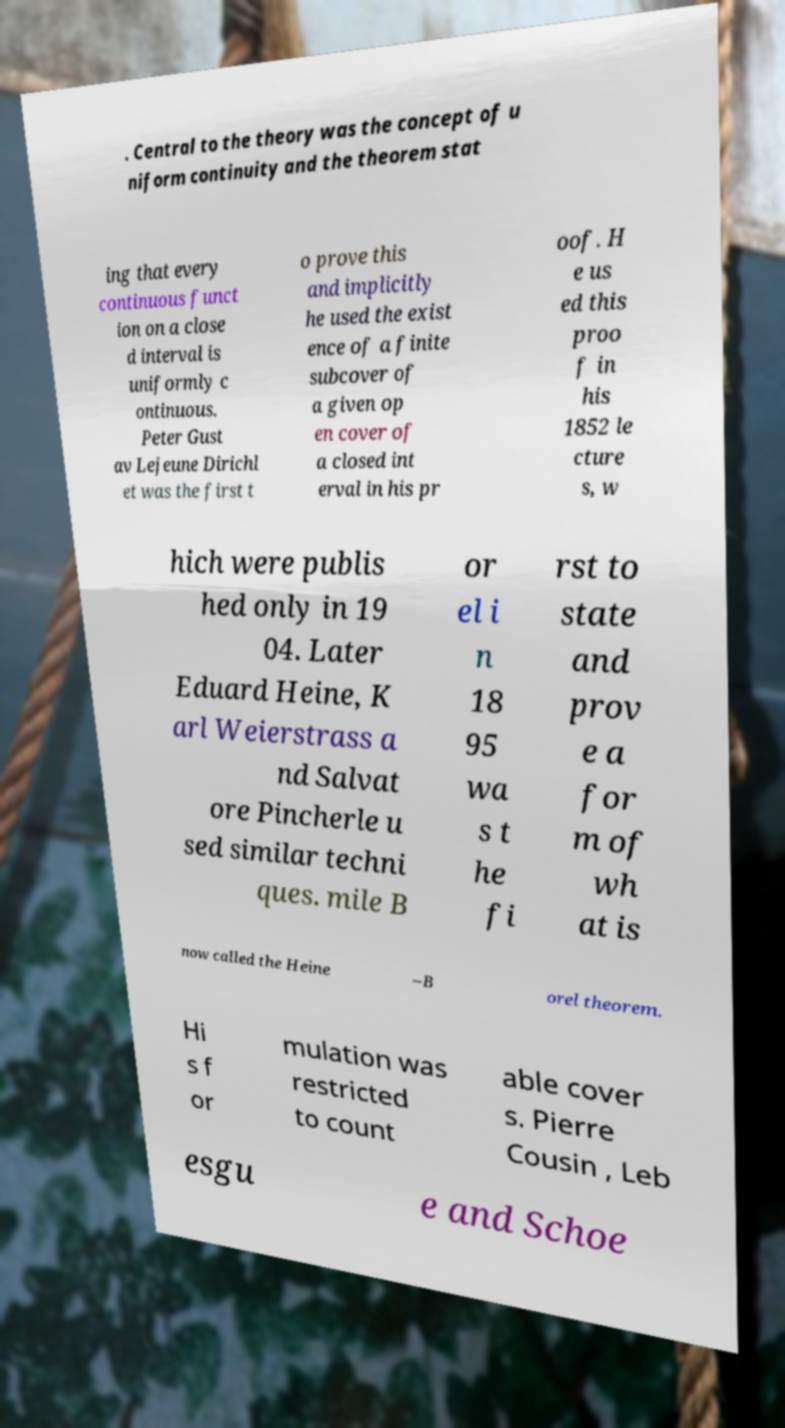Please identify and transcribe the text found in this image. . Central to the theory was the concept of u niform continuity and the theorem stat ing that every continuous funct ion on a close d interval is uniformly c ontinuous. Peter Gust av Lejeune Dirichl et was the first t o prove this and implicitly he used the exist ence of a finite subcover of a given op en cover of a closed int erval in his pr oof. H e us ed this proo f in his 1852 le cture s, w hich were publis hed only in 19 04. Later Eduard Heine, K arl Weierstrass a nd Salvat ore Pincherle u sed similar techni ques. mile B or el i n 18 95 wa s t he fi rst to state and prov e a for m of wh at is now called the Heine –B orel theorem. Hi s f or mulation was restricted to count able cover s. Pierre Cousin , Leb esgu e and Schoe 